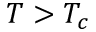Convert formula to latex. <formula><loc_0><loc_0><loc_500><loc_500>T > T _ { c }</formula> 